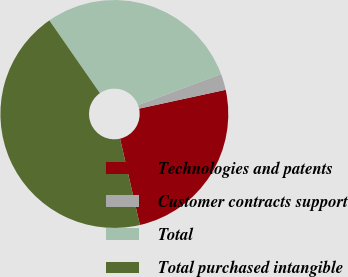Convert chart. <chart><loc_0><loc_0><loc_500><loc_500><pie_chart><fcel>Technologies and patents<fcel>Customer contracts support<fcel>Total<fcel>Total purchased intangible<nl><fcel>24.8%<fcel>2.3%<fcel>28.96%<fcel>43.94%<nl></chart> 